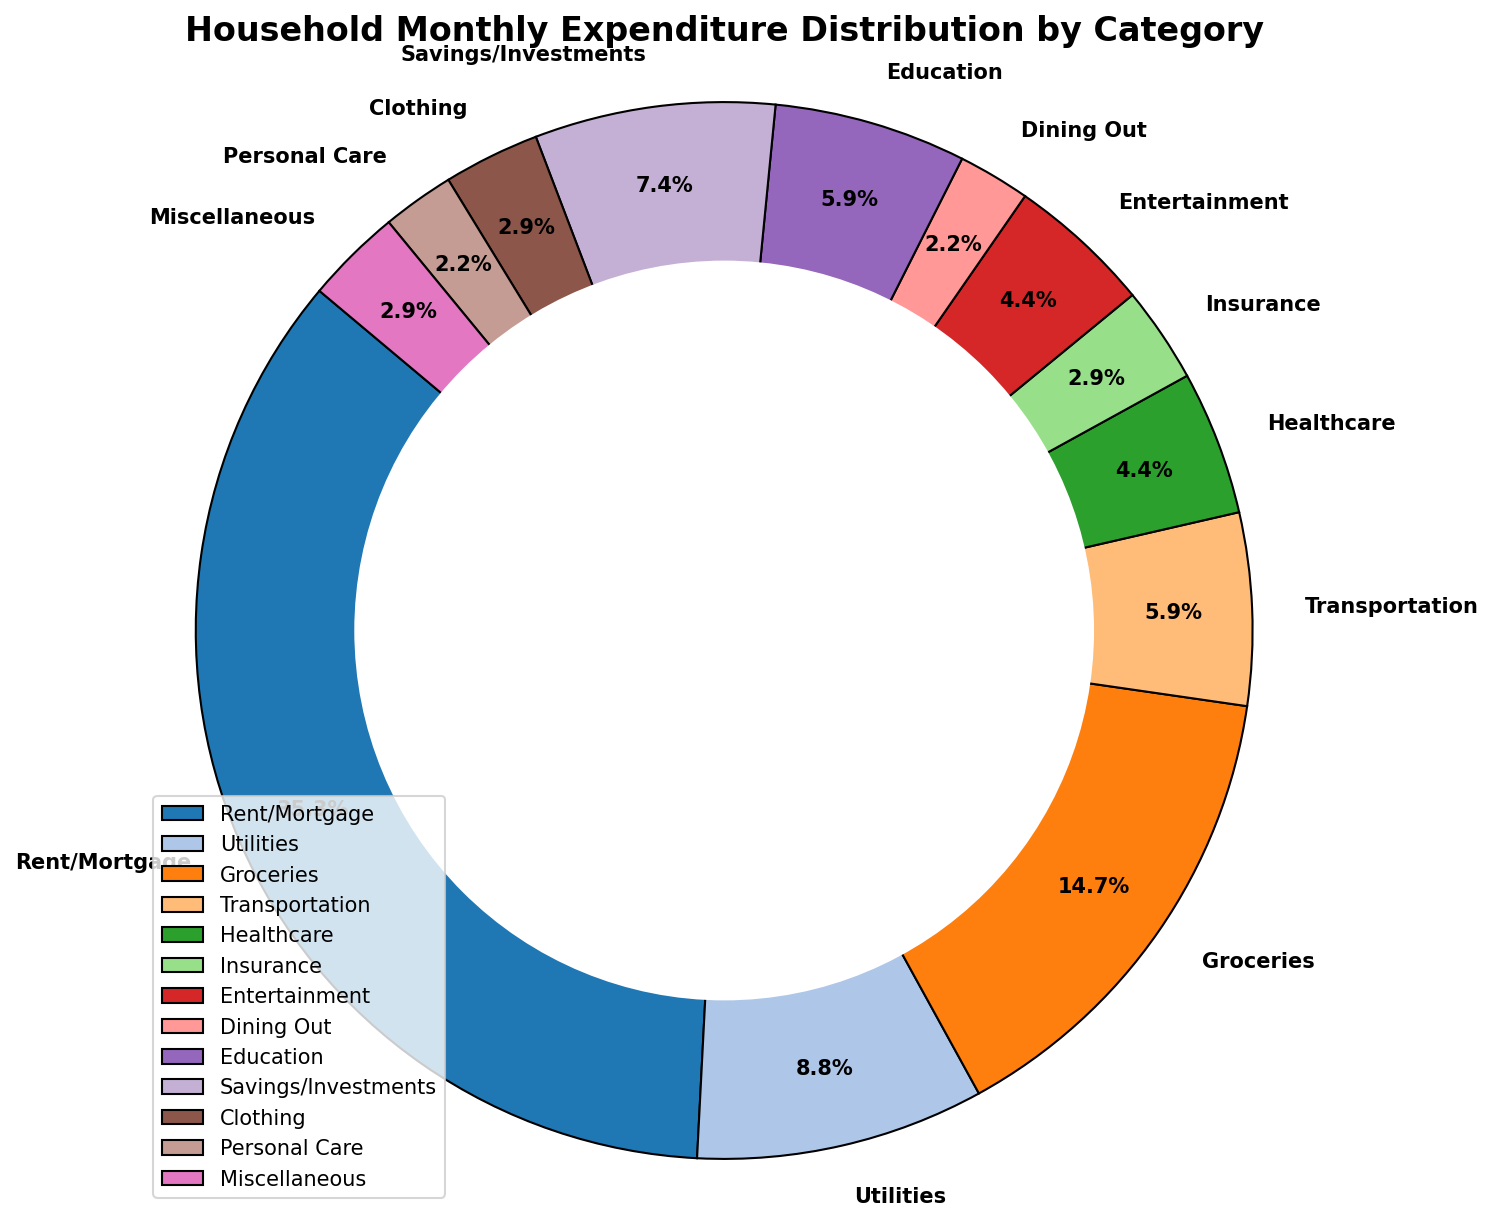Which category has the highest expenditure? The figure shows that the "Rent/Mortgage" category has the largest slice compared to other categories, indicating the highest expenditure.
Answer: Rent/Mortgage Which category has the lowest expenditure? From the figure, "Dining Out" and "Personal Care" have the smallest slices, and since "Dining Out" is listed as $75 expenditure, it's the lowest.
Answer: Dining Out What percentage of the total expenditure is spent on Groceries? The figure's "Groceries" slice has a label of 500. To find the percentage, we divide 500 by the total expenditure and multiply by 100. Total expenditure is 3400 (sum of all categories). So, (500/3400) * 100 = 14.7%.
Answer: 14.7% How much more is spent on Rent/Mortgage than Entertainment? The figure shows Rent/Mortgage at $1200 and Entertainment at $150. The difference is 1200 - 150 = 1050.
Answer: 1050 Which categories have an expenditure greater than $300? From the figure, "Rent/Mortgage" at $1200, "Groceries" at $500, and "Utilities" at $300 meet this criteria.
Answer: Rent/Mortgage, Groceries Which category's expenditure is closest to the average expenditure per category? The average expenditure is calculated as total expenditure divided by the number of categories. The total expenditure is $3400 divided by 13 categories equals approximately $261.5. The category with expenditure closest to $261.5 is "Savings/Investments" at $250.
Answer: Savings/Investments What is the combined expenditure for Healthcare, Insurance, and Personal Care? From the figure, "Healthcare" is $150, "Insurance" is $100, and "Personal Care" is $75. The combined expenditure is 150 + 100 + 75 = 325.
Answer: 325 What percentage of total expenditure is on Utilities and Transportation combined? The figure shows "Utilities" at $300 and "Transportation" at $200, so the combined expenditure is 300 + 200 = 500. To find this percentage of the total expenditure ($3400), we do (500/3400) * 100 = 14.7%.
Answer: 14.7% Is the expenditure on Education more, less, or equal to the expenditure on Dining Out and Clothing combined? According to the figure, "Education" is $200. "Dining Out" is $75 and "Clothing" is $100. Combined, Dining Out and Clothing sum up to 75 + 100 = 175, which is less.
Answer: More Which three categories have expenditures closest to each other? The figure shows that "Utilities" at $300, "Groceries" at $500, "Entertainment" at $150, "Healthcare" at $150, "Insurance" at $100, and "Miscellaneous" at $100 are close. The closest are "Insurance," "Clothing," and "Miscellaneous," each at $100.
Answer: Insurance, Clothing, Miscellaneous 